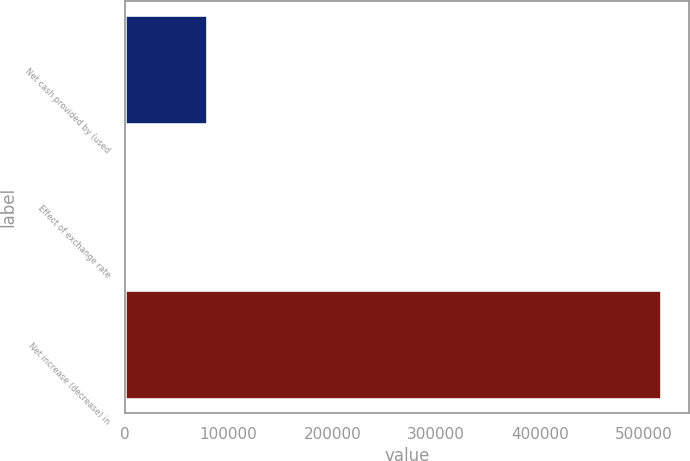<chart> <loc_0><loc_0><loc_500><loc_500><bar_chart><fcel>Net cash provided by (used<fcel>Effect of exchange rate<fcel>Net increase (decrease) in<nl><fcel>80408.4<fcel>1404<fcel>517471<nl></chart> 